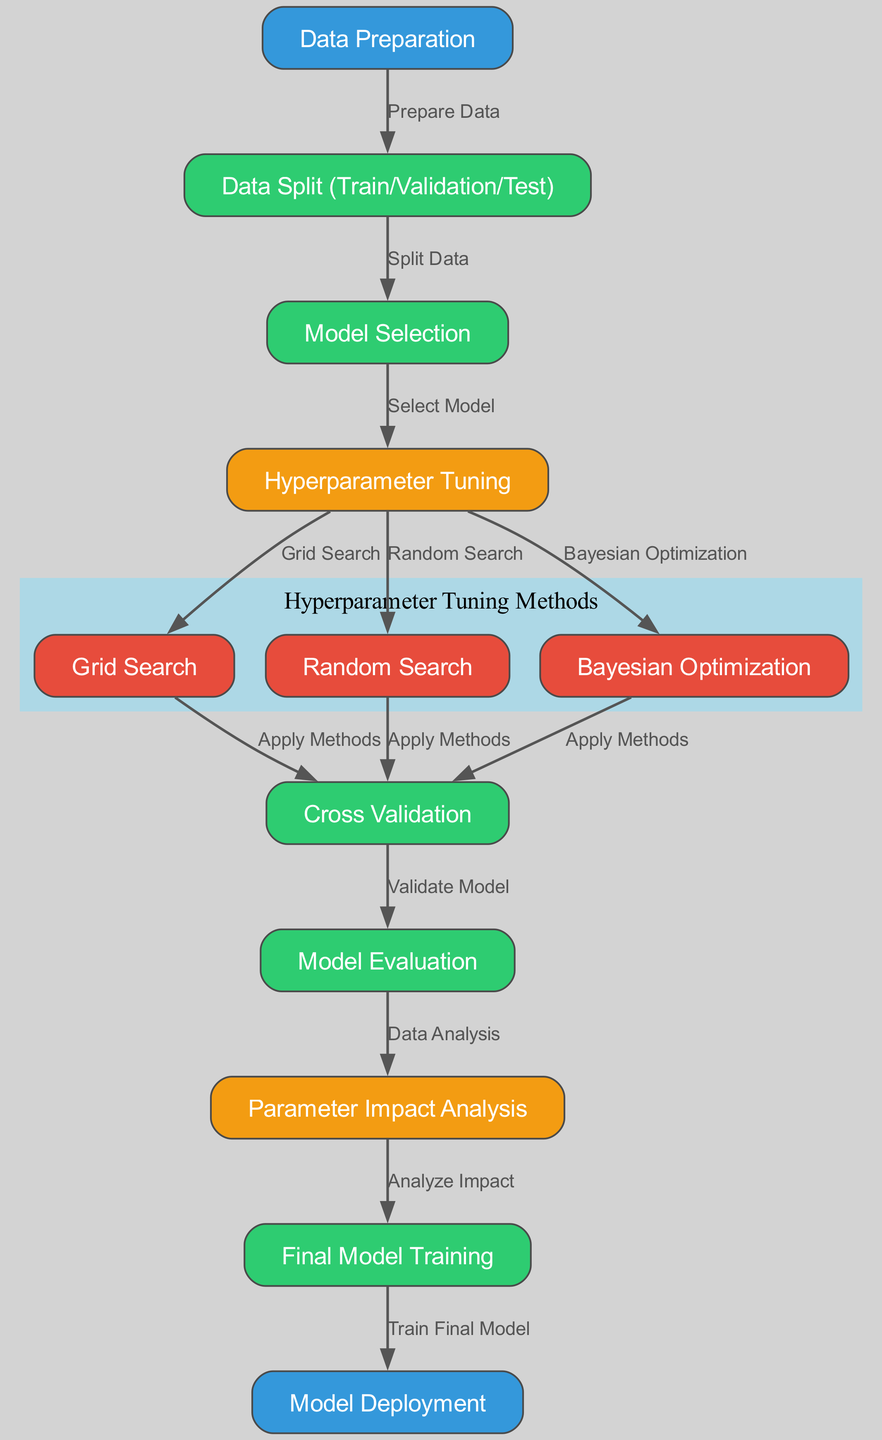What is the first step in the workflow? The first step is "Data Preparation," which is the initial process before any model selection or tuning takes place.
Answer: Data Preparation How many main hyperparameter tuning methods are shown in the diagram? The diagram lists three main hyperparameter tuning methods: Grid Search, Random Search, and Bayesian Optimization.
Answer: 3 Which node directly follows "Model Evaluation"? The node that directly follows "Model Evaluation" is "Parameter Impact Analysis," indicating the sequence of steps after the evaluation is complete.
Answer: Parameter Impact Analysis What is the relationship between "Hyperparameter Tuning" and "Grid Search"? The relationship is that "Hyperparameter Tuning" uses "Grid Search" as one of its methods for tuning the model’s hyperparameters.
Answer: Select Model Which process follows the "Parameter Impact Analysis"? The process that follows "Parameter Impact Analysis" is "Final Model Training," suggesting that after analyzing parameter impacts, the final model is trained.
Answer: Final Model Training Which node connects to both "Random Search" and "Bayesian Optimization"? The "Cross Validation" node connects to both "Random Search" and "Bayesian Optimization," indicating that both methods will undergo cross-validation for evaluation.
Answer: Cross Validation How does "Data Split (Train/Validation/Test)" relate to "Model Selection"? "Data Split (Train/Validation/Test)" is the process that leads to "Model Selection," illustrating that data must be split before selecting a model to train.
Answer: Split Data What is the color of the nodes representing hyperparameter tuning methods? The hyperparameter tuning methods are represented with a red color, emphasizing their role within the workflow.
Answer: Red 